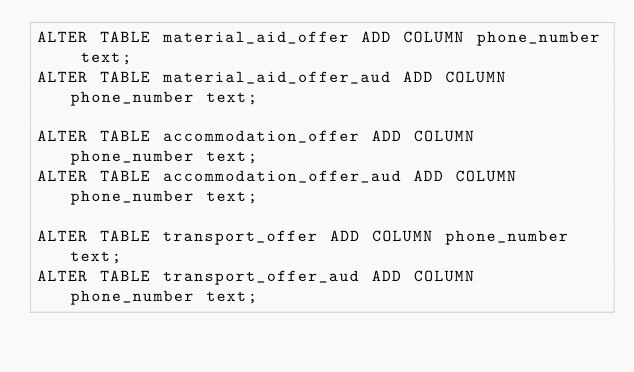<code> <loc_0><loc_0><loc_500><loc_500><_SQL_>ALTER TABLE material_aid_offer ADD COLUMN phone_number text;
ALTER TABLE material_aid_offer_aud ADD COLUMN phone_number text;

ALTER TABLE accommodation_offer ADD COLUMN phone_number text;
ALTER TABLE accommodation_offer_aud ADD COLUMN phone_number text;

ALTER TABLE transport_offer ADD COLUMN phone_number text;
ALTER TABLE transport_offer_aud ADD COLUMN phone_number text;
</code> 